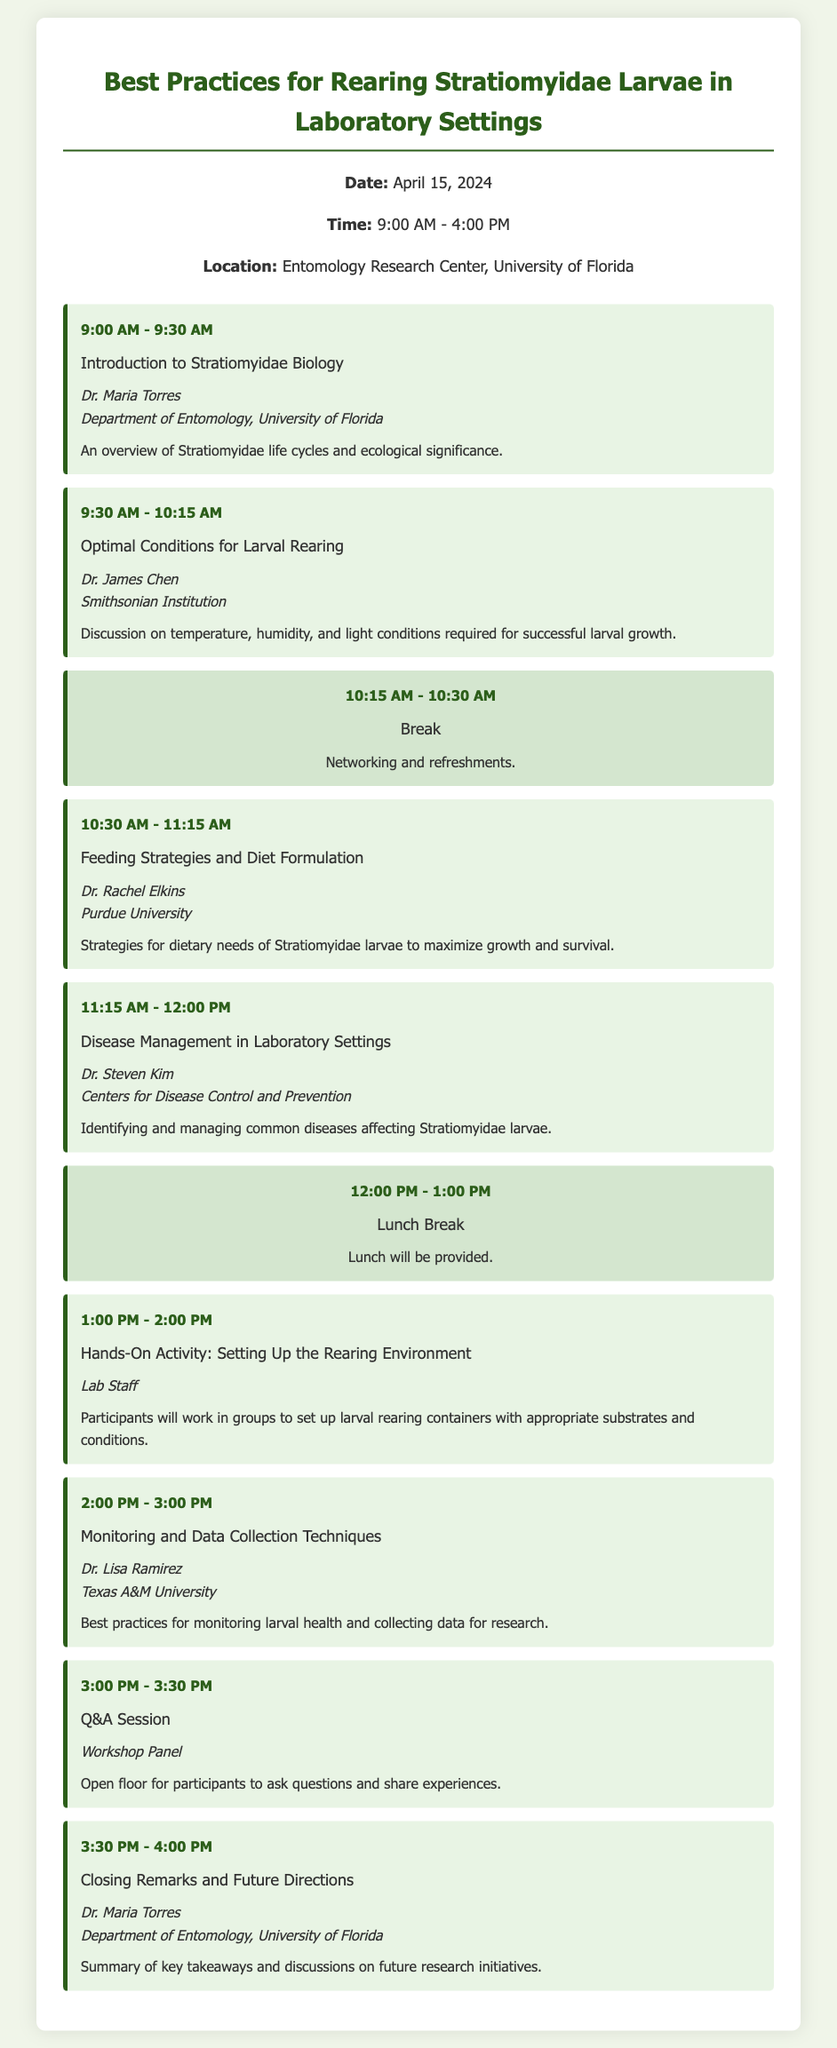What is the date of the workshop? The date of the workshop is provided in the document, explicitly stating "April 15, 2024".
Answer: April 15, 2024 Who is the speaker for the session on "Optimal Conditions for Larval Rearing"? Information about speakers is given for each session; for "Optimal Conditions for Larval Rearing," it mentions "Dr. James Chen".
Answer: Dr. James Chen What is the duration of the "Break"? The schedule lists the "Break" session as starting at 10:15 AM and ending at 10:30 AM, indicating a duration of 15 minutes.
Answer: 15 minutes Which university is Dr. Rachel Elkins affiliated with? The affiliation for Dr. Rachel Elkins is noted in the document under her name, identifying her as part of "Purdue University".
Answer: Purdue University How many hands-on activities are mentioned in the agenda? The agenda includes one hands-on activity titled "Hands-On Activity: Setting Up the Rearing Environment".
Answer: One What is the main focus of the Q&A session? The document explains that the Q&A session allows participants to "ask questions and share experiences," indicating its interactive purpose.
Answer: Questions and experiences Who provides the "Closing Remarks and Future Directions"? The document specifies that Dr. Maria Torres is responsible for delivering the "Closing Remarks and Future Directions".
Answer: Dr. Maria Torres What type of refreshments are mentioned during the break? The break session describes it simply as "Networking and refreshments", without specifying the type.
Answer: Refreshments What topic will Dr. Lisa Ramirez discuss? The agenda specifies the topic as "Monitoring and Data Collection Techniques", which is under Dr. Lisa Ramirez's session.
Answer: Monitoring and Data Collection Techniques 